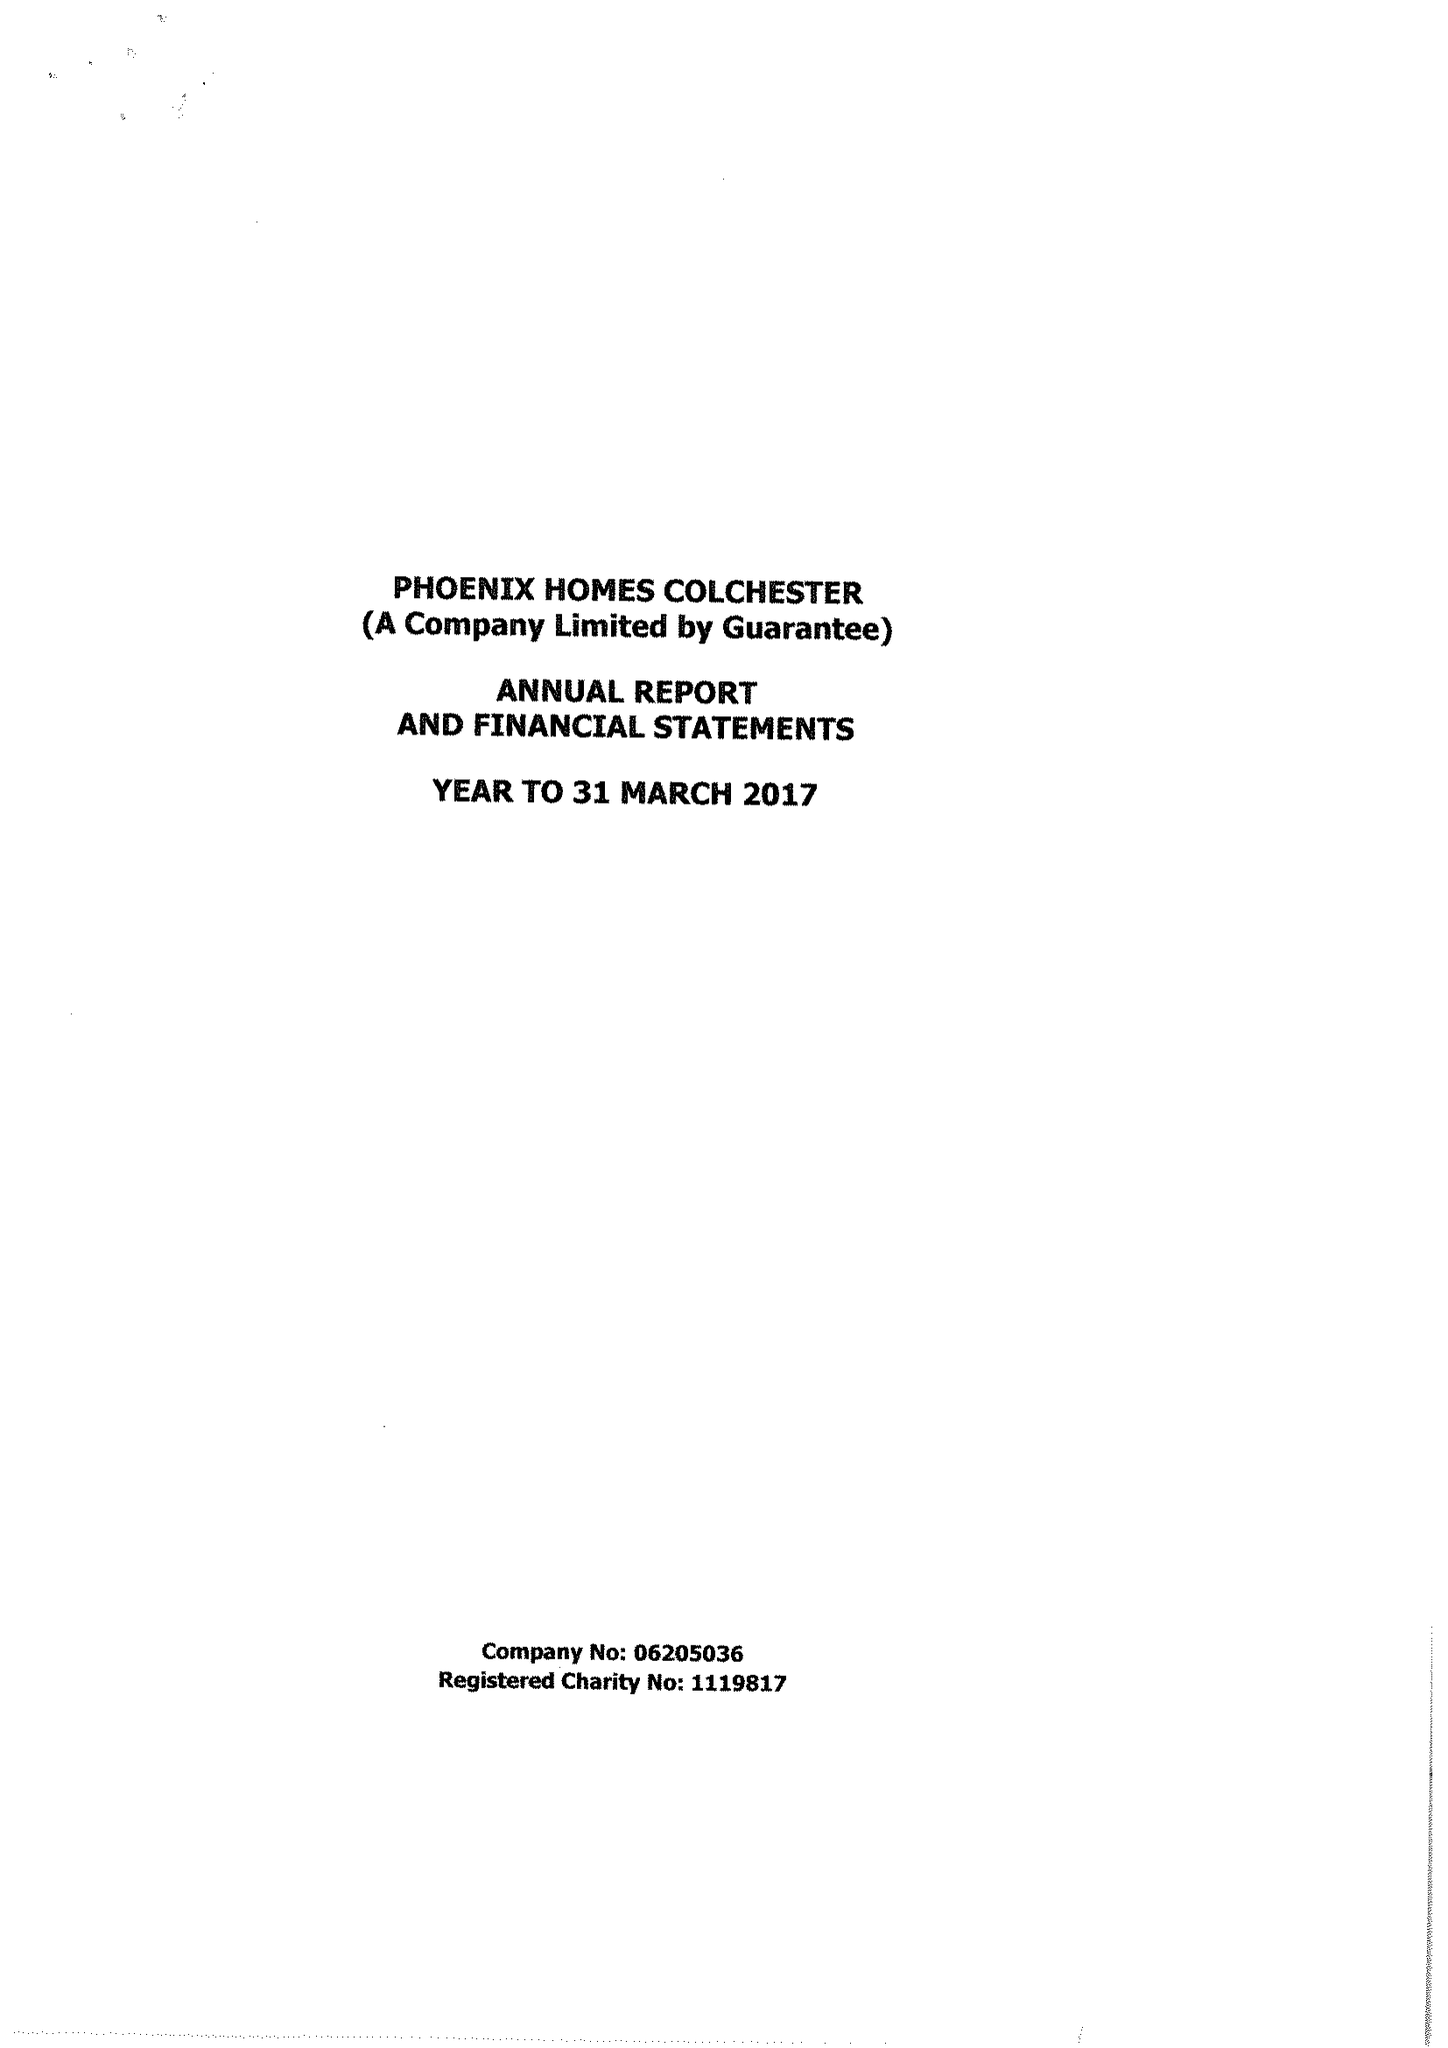What is the value for the report_date?
Answer the question using a single word or phrase. 2017-03-31 